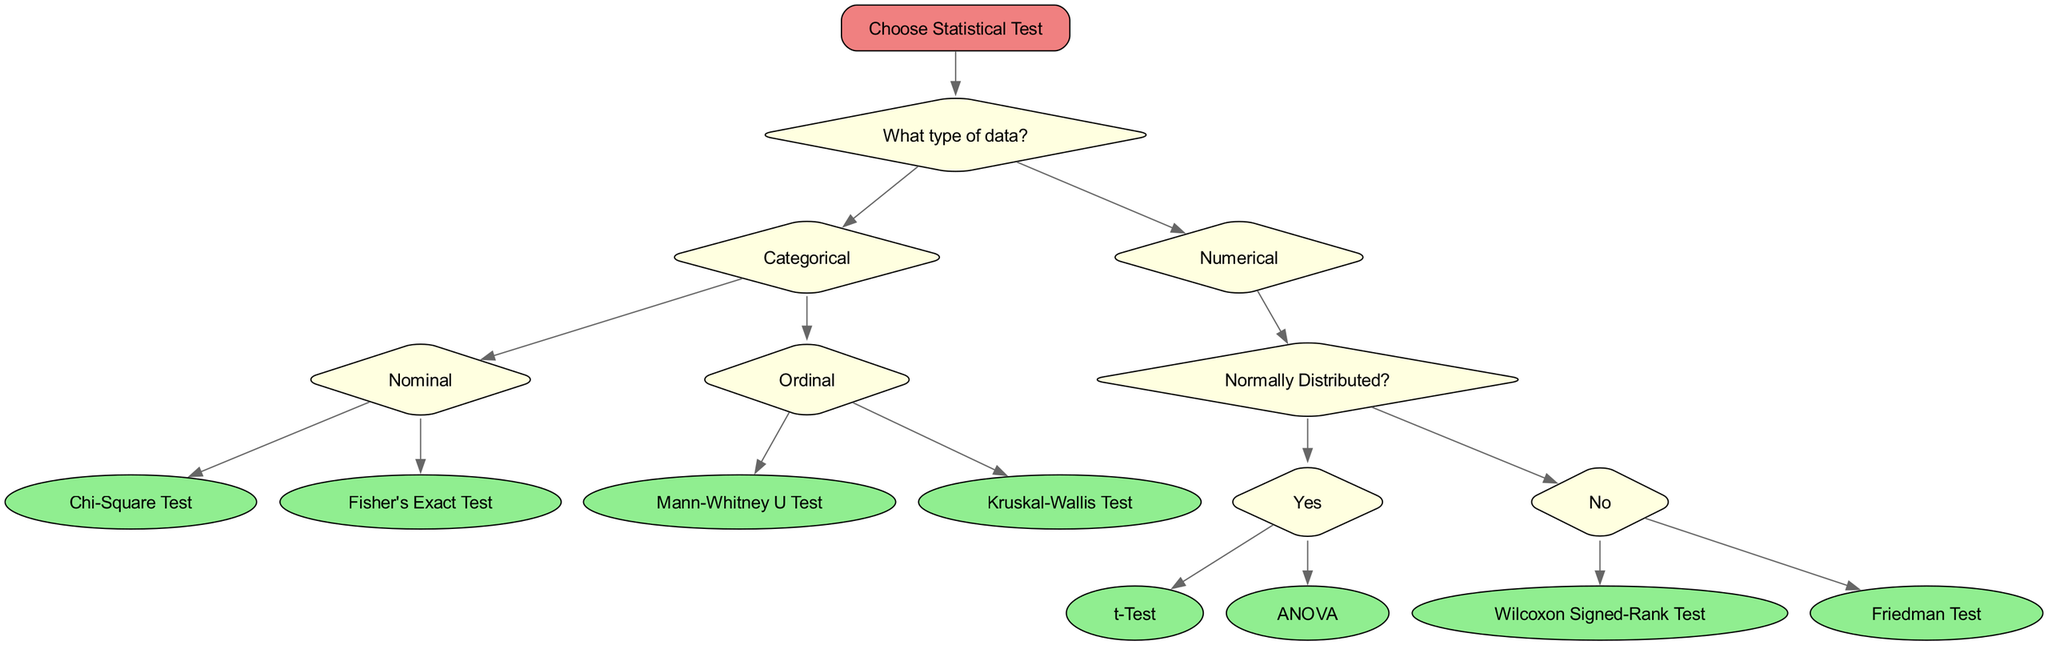What is the root node of the diagram? The root node is labeled "Choose Statistical Test," which is the starting point of the decision tree.
Answer: Choose Statistical Test How many types of data are there in the diagram? The diagram presents two main types of data: Categorical and Numerical, which are the first two branches stemming from the root node.
Answer: 2 Which test is associated with nominal data? The Chi-Square Test is indicated as a statistical test that is used specifically for nominal data within the decision tree.
Answer: Chi-Square Test What is the next node if the data type is Numerical and it is normally distributed? If the data type is Numerical and it is identified as Normally Distributed, the next nodes available are the t-Test and ANOVA.
Answer: t-Test, ANOVA If the data type is Categorical and Ordinal, which tests can be used? For Categorical data that is classified as Ordinal, the tests indicated in the diagram are the Mann-Whitney U Test and the Kruskal-Wallis Test.
Answer: Mann-Whitney U Test, Kruskal-Wallis Test How many tests are listed under Numerical data when it is not normally distributed? The diagram shows two tests available when the Numerical data is not normally distributed: the Wilcoxon Signed-Rank Test and the Friedman Test.
Answer: 2 What is the connection between "Normally Distributed?" and "t-Test"? The "Normally Distributed?" node branches into "Yes" and "No." If a user answers "Yes," they can proceed directly to either the t-Test or ANOVA, showing a direct relationship where "t-Test" is an option following the affirmative answer.
Answer: t-Test In total, how many child nodes does the "Numerical" category have? The "Numerical" category has a total of three child nodes: "Normally Distributed?" followed by its two test options, and additionally it does not include child nodes for non-normal distribution tests.
Answer: 1 